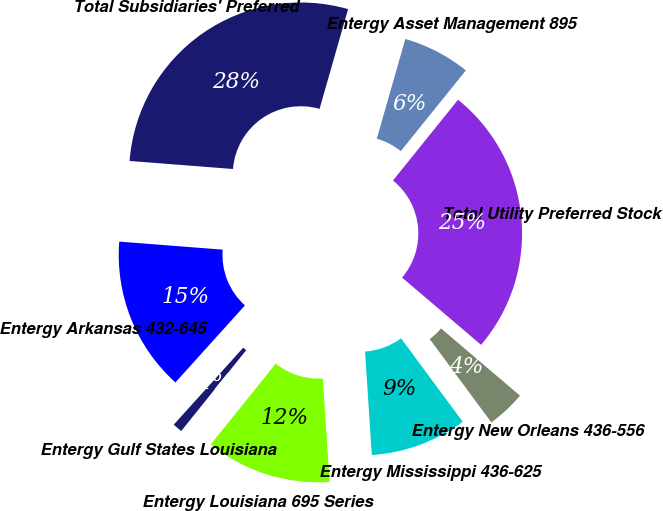Convert chart. <chart><loc_0><loc_0><loc_500><loc_500><pie_chart><fcel>Entergy Arkansas 432-645<fcel>Entergy Gulf States Louisiana<fcel>Entergy Louisiana 695 Series<fcel>Entergy Mississippi 436-625<fcel>Entergy New Orleans 436-556<fcel>Total Utility Preferred Stock<fcel>Entergy Asset Management 895<fcel>Total Subsidiaries' Preferred<nl><fcel>14.55%<fcel>0.91%<fcel>11.82%<fcel>9.09%<fcel>3.64%<fcel>25.43%<fcel>6.36%<fcel>28.2%<nl></chart> 